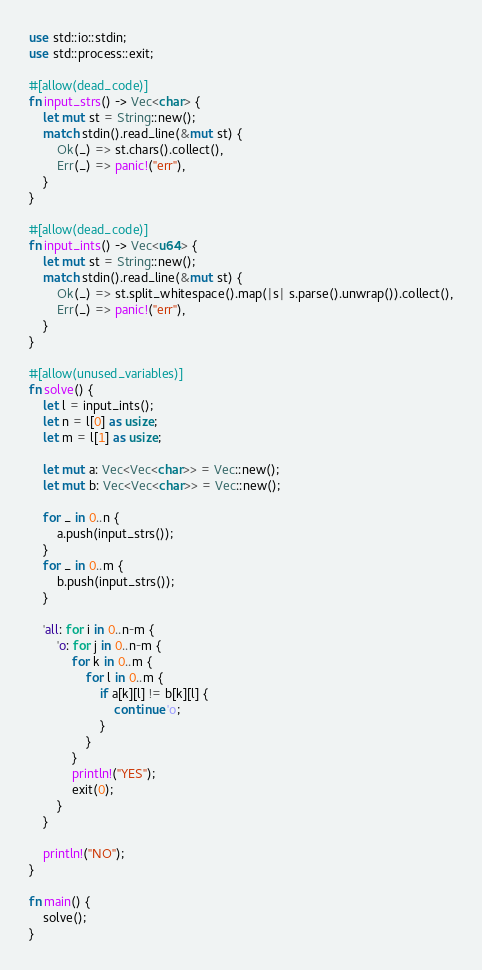<code> <loc_0><loc_0><loc_500><loc_500><_Rust_>use std::io::stdin;
use std::process::exit;

#[allow(dead_code)]
fn input_strs() -> Vec<char> {
    let mut st = String::new();
    match stdin().read_line(&mut st) {
        Ok(_) => st.chars().collect(),
        Err(_) => panic!("err"),
    }
}
 
#[allow(dead_code)]
fn input_ints() -> Vec<u64> {
    let mut st = String::new();
    match stdin().read_line(&mut st) {
        Ok(_) => st.split_whitespace().map(|s| s.parse().unwrap()).collect(),
        Err(_) => panic!("err"),
    }
}
 
#[allow(unused_variables)]
fn solve() {
    let l = input_ints();
    let n = l[0] as usize;
    let m = l[1] as usize;

    let mut a: Vec<Vec<char>> = Vec::new();
    let mut b: Vec<Vec<char>> = Vec::new();

    for _ in 0..n {
        a.push(input_strs());
    }
    for _ in 0..m {
        b.push(input_strs());
    }

    'all: for i in 0..n-m {
        'o: for j in 0..n-m {
            for k in 0..m {
                for l in 0..m {
                    if a[k][l] != b[k][l] {
                        continue 'o;
                    }
                }
            }
            println!("YES");
            exit(0);
        }
    }

    println!("NO");
}
 
fn main() {
    solve();
}
</code> 